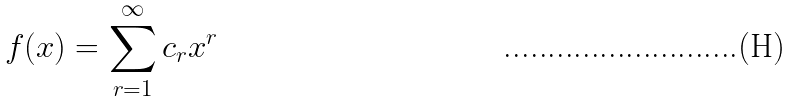Convert formula to latex. <formula><loc_0><loc_0><loc_500><loc_500>f ( x ) = \sum _ { r = 1 } ^ { \infty } c _ { r } x ^ { r }</formula> 